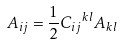<formula> <loc_0><loc_0><loc_500><loc_500>A _ { i j } = \frac { 1 } { 2 } { C _ { i j } } ^ { k l } { A _ { k l } }</formula> 